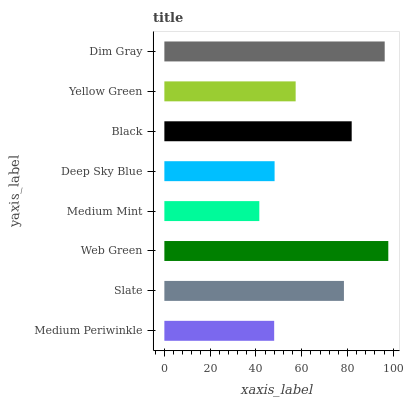Is Medium Mint the minimum?
Answer yes or no. Yes. Is Web Green the maximum?
Answer yes or no. Yes. Is Slate the minimum?
Answer yes or no. No. Is Slate the maximum?
Answer yes or no. No. Is Slate greater than Medium Periwinkle?
Answer yes or no. Yes. Is Medium Periwinkle less than Slate?
Answer yes or no. Yes. Is Medium Periwinkle greater than Slate?
Answer yes or no. No. Is Slate less than Medium Periwinkle?
Answer yes or no. No. Is Slate the high median?
Answer yes or no. Yes. Is Yellow Green the low median?
Answer yes or no. Yes. Is Black the high median?
Answer yes or no. No. Is Web Green the low median?
Answer yes or no. No. 